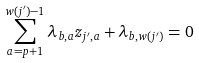<formula> <loc_0><loc_0><loc_500><loc_500>\sum _ { a = p + 1 } ^ { w ( j ^ { \prime } ) - 1 } \lambda _ { b , a } z _ { j ^ { \prime } , a } + \lambda _ { b , w ( j ^ { \prime } ) } = 0</formula> 